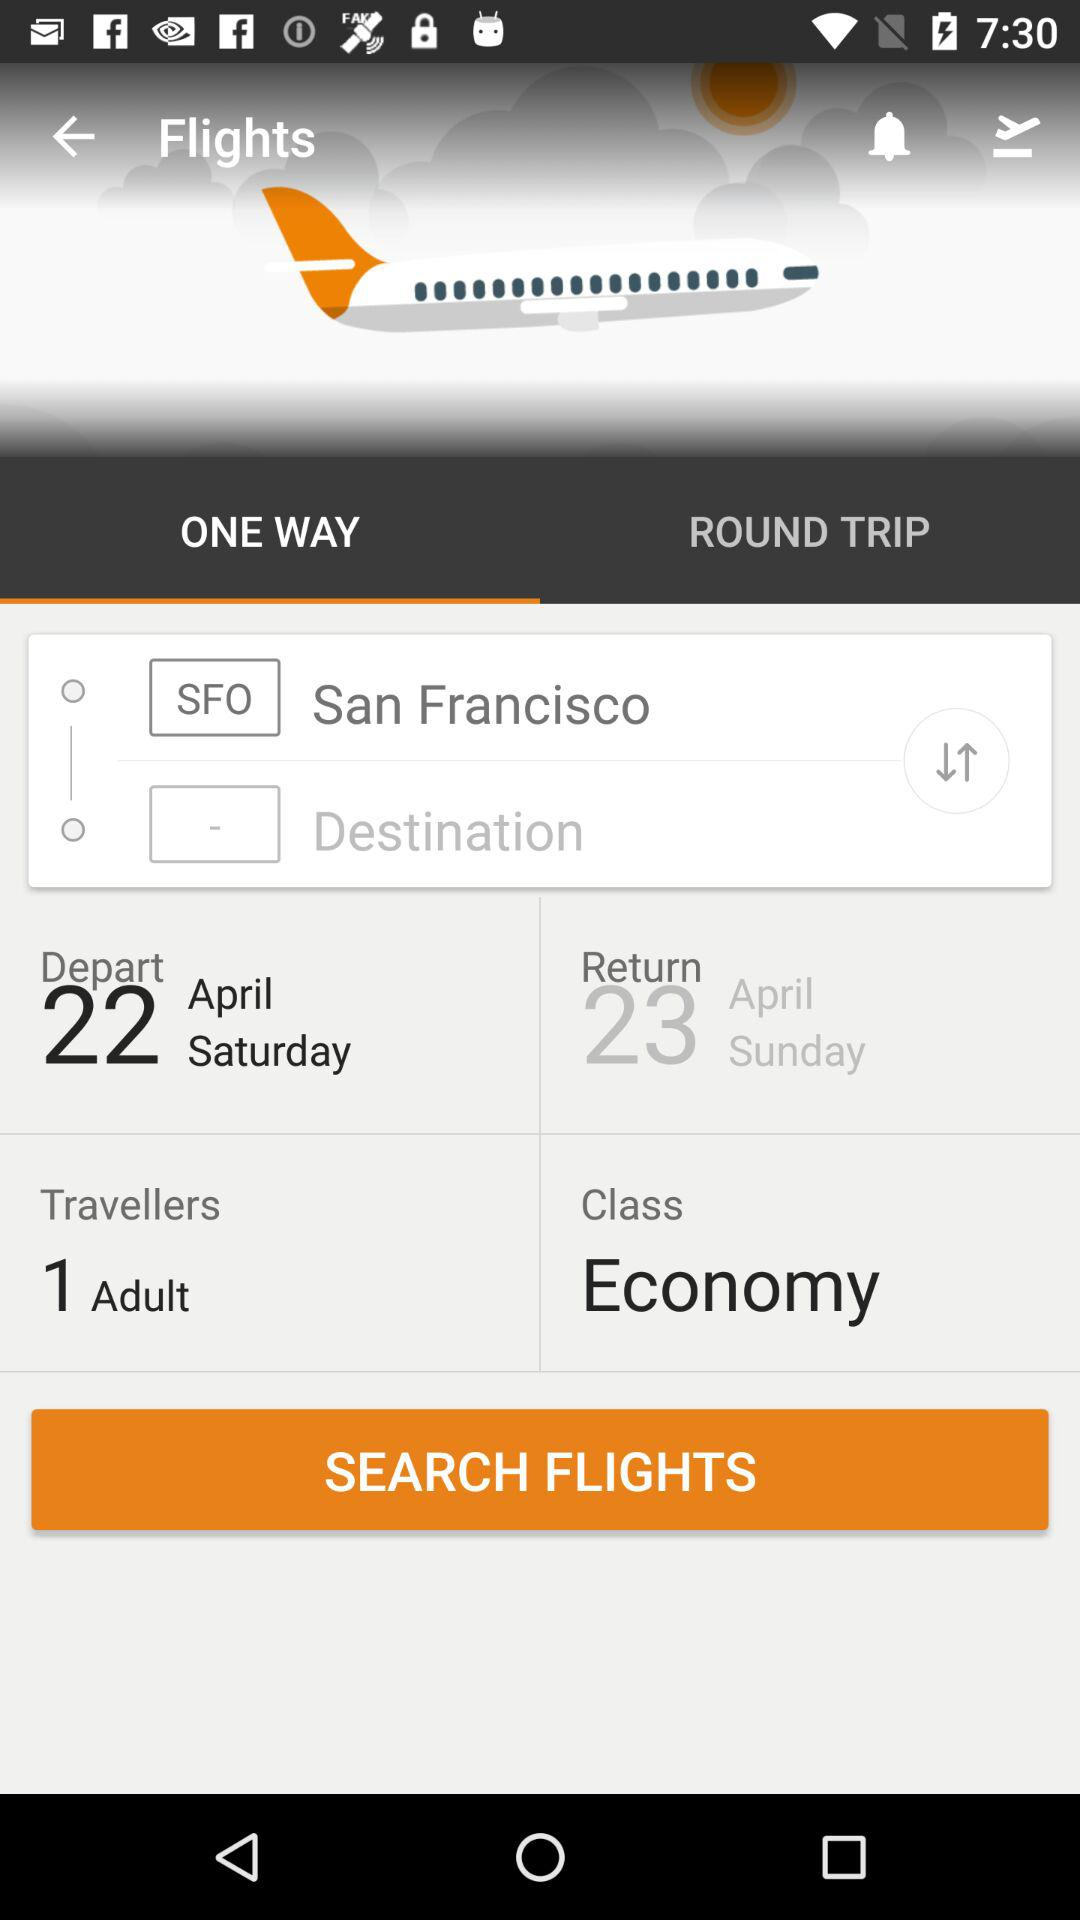Which option is selected in flights? The selected option is "ONE WAY". 